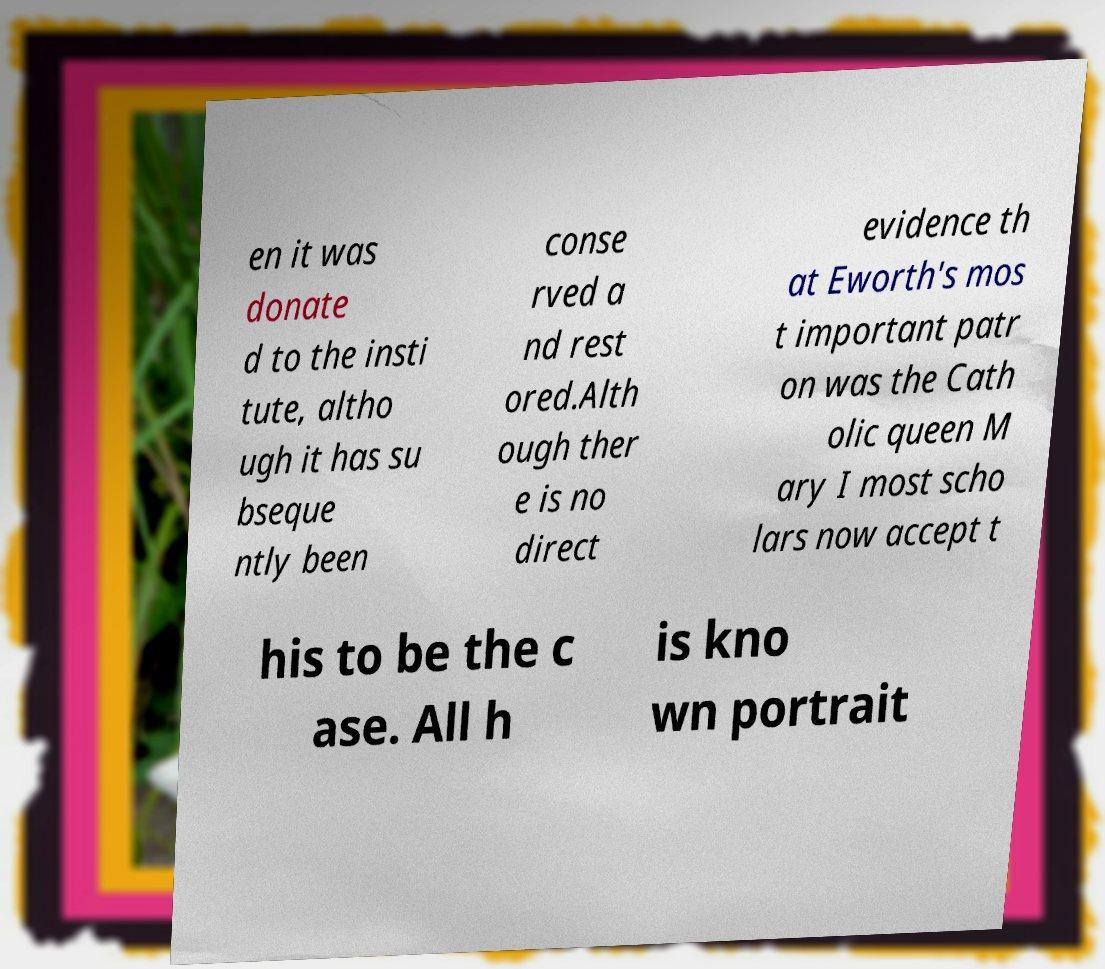Can you read and provide the text displayed in the image?This photo seems to have some interesting text. Can you extract and type it out for me? en it was donate d to the insti tute, altho ugh it has su bseque ntly been conse rved a nd rest ored.Alth ough ther e is no direct evidence th at Eworth's mos t important patr on was the Cath olic queen M ary I most scho lars now accept t his to be the c ase. All h is kno wn portrait 